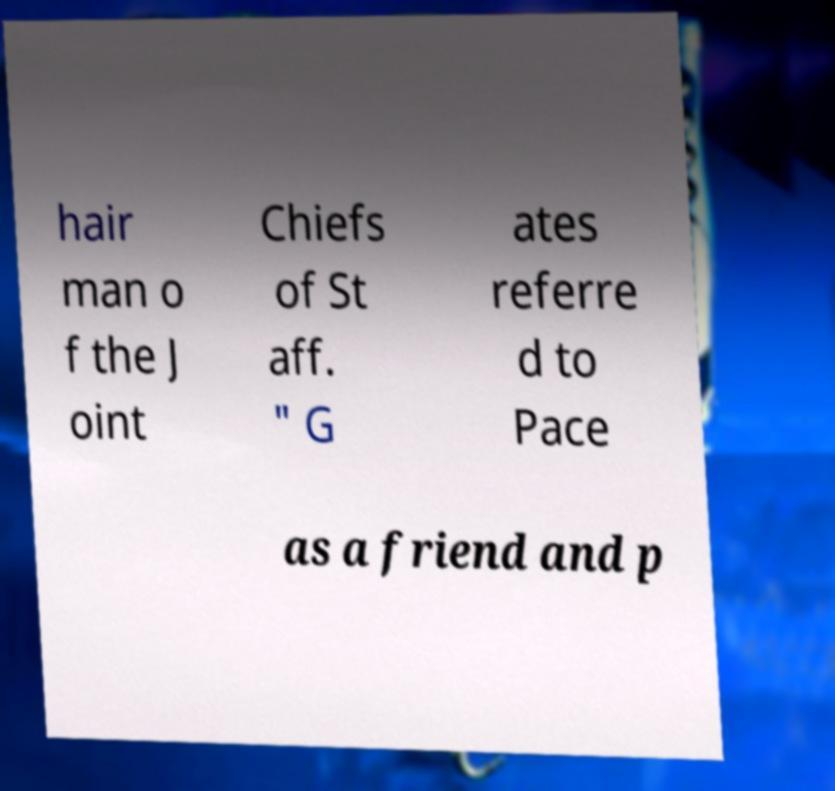I need the written content from this picture converted into text. Can you do that? hair man o f the J oint Chiefs of St aff. " G ates referre d to Pace as a friend and p 